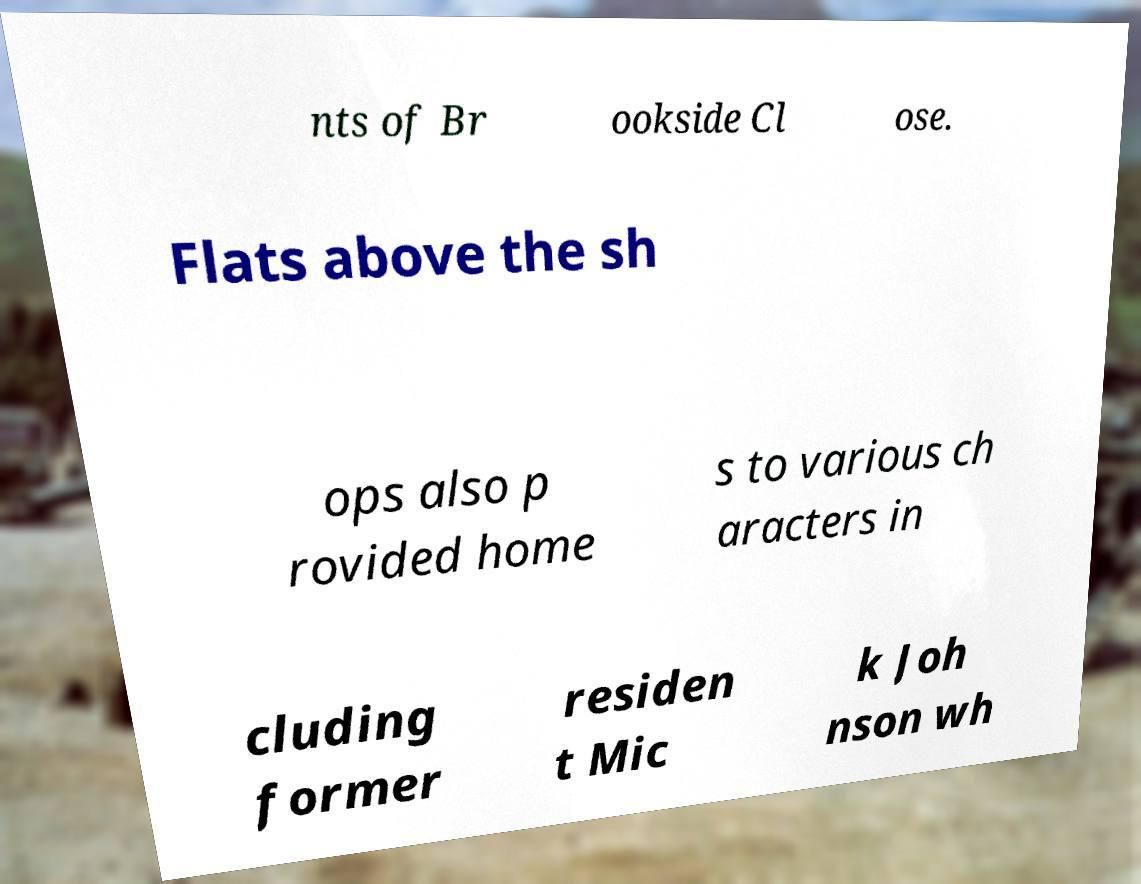I need the written content from this picture converted into text. Can you do that? nts of Br ookside Cl ose. Flats above the sh ops also p rovided home s to various ch aracters in cluding former residen t Mic k Joh nson wh 